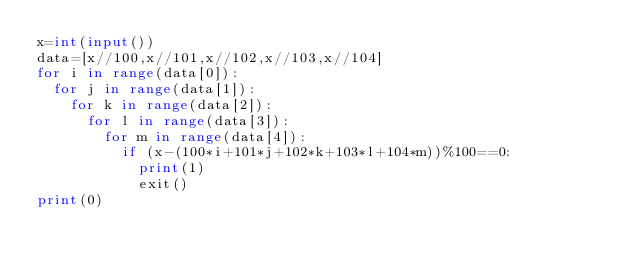Convert code to text. <code><loc_0><loc_0><loc_500><loc_500><_Python_>x=int(input())
data=[x//100,x//101,x//102,x//103,x//104]
for i in range(data[0]):
  for j in range(data[1]):
    for k in range(data[2]):
      for l in range(data[3]):
        for m in range(data[4]):
          if (x-(100*i+101*j+102*k+103*l+104*m))%100==0:
            print(1)
            exit()
print(0)</code> 